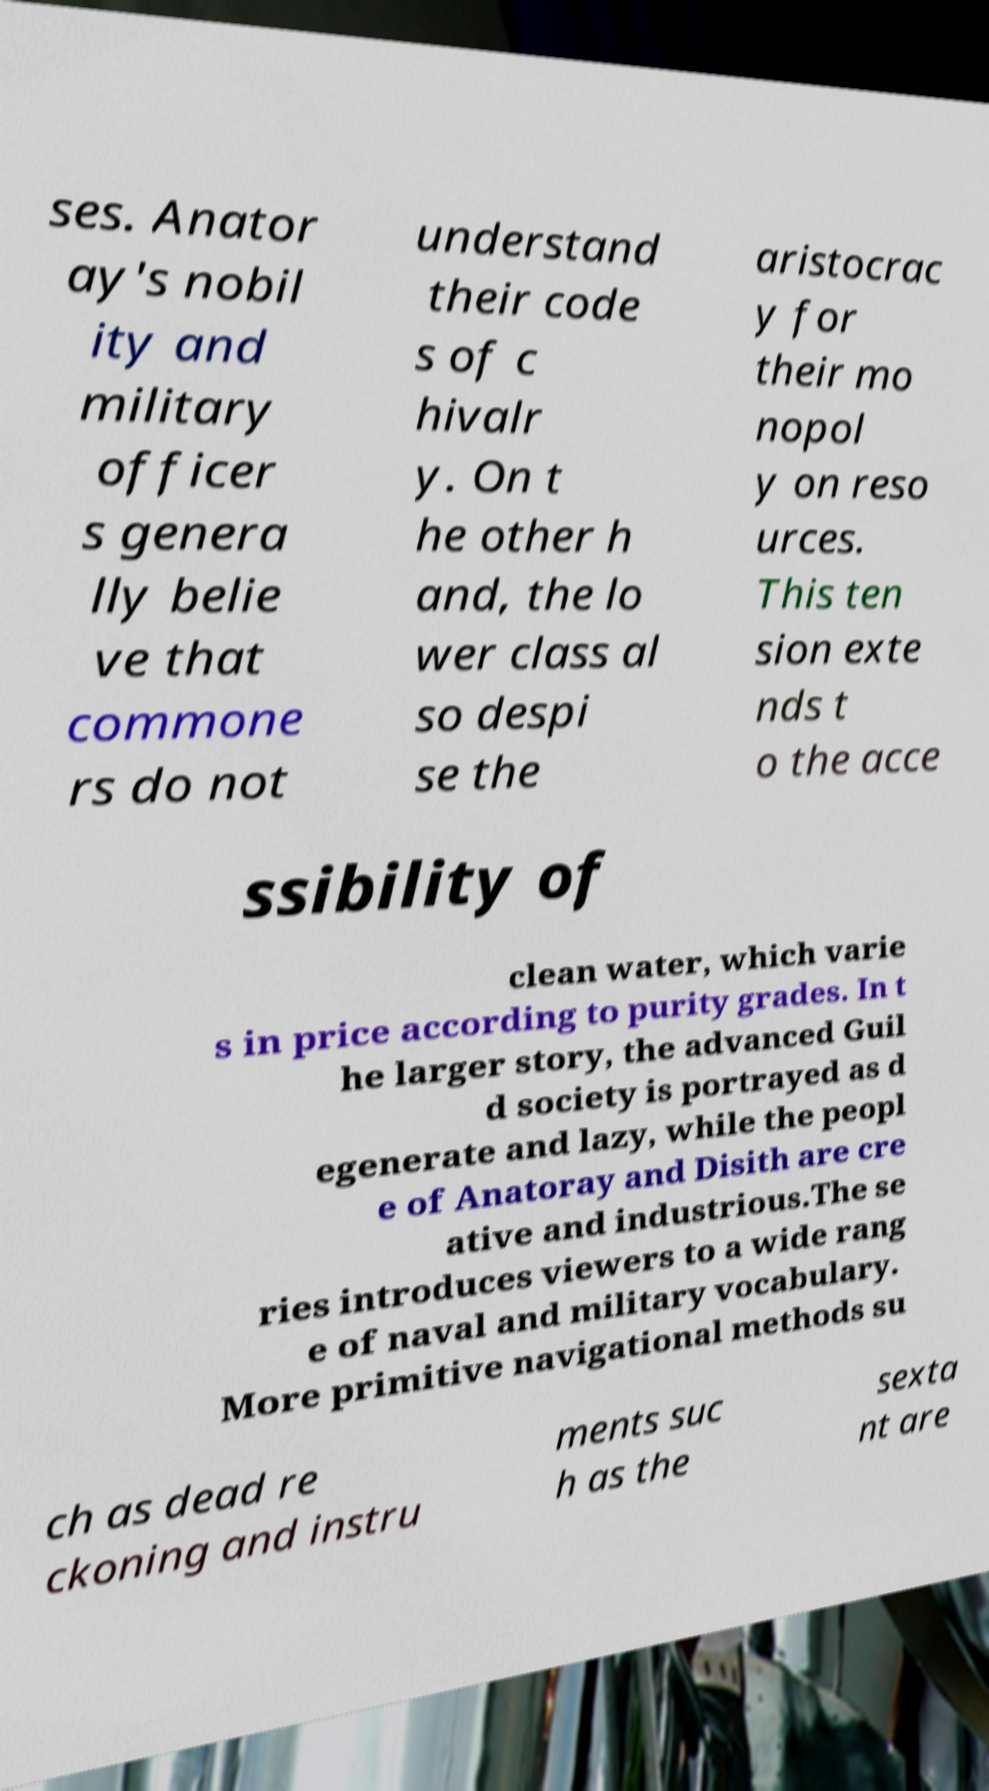Please identify and transcribe the text found in this image. ses. Anator ay's nobil ity and military officer s genera lly belie ve that commone rs do not understand their code s of c hivalr y. On t he other h and, the lo wer class al so despi se the aristocrac y for their mo nopol y on reso urces. This ten sion exte nds t o the acce ssibility of clean water, which varie s in price according to purity grades. In t he larger story, the advanced Guil d society is portrayed as d egenerate and lazy, while the peopl e of Anatoray and Disith are cre ative and industrious.The se ries introduces viewers to a wide rang e of naval and military vocabulary. More primitive navigational methods su ch as dead re ckoning and instru ments suc h as the sexta nt are 